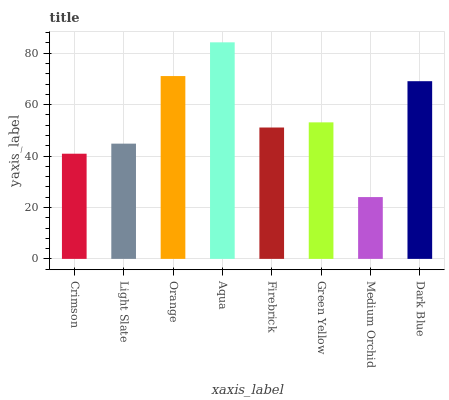Is Light Slate the minimum?
Answer yes or no. No. Is Light Slate the maximum?
Answer yes or no. No. Is Light Slate greater than Crimson?
Answer yes or no. Yes. Is Crimson less than Light Slate?
Answer yes or no. Yes. Is Crimson greater than Light Slate?
Answer yes or no. No. Is Light Slate less than Crimson?
Answer yes or no. No. Is Green Yellow the high median?
Answer yes or no. Yes. Is Firebrick the low median?
Answer yes or no. Yes. Is Crimson the high median?
Answer yes or no. No. Is Green Yellow the low median?
Answer yes or no. No. 